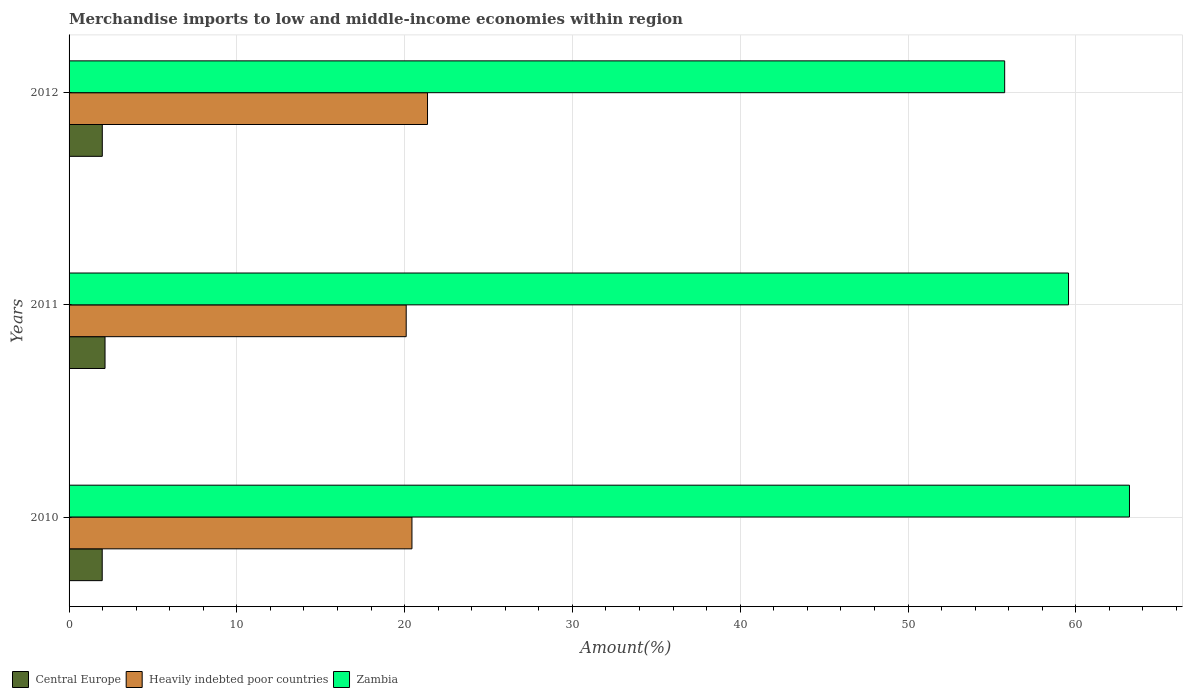How many different coloured bars are there?
Offer a terse response. 3. Are the number of bars on each tick of the Y-axis equal?
Make the answer very short. Yes. How many bars are there on the 1st tick from the top?
Make the answer very short. 3. How many bars are there on the 1st tick from the bottom?
Your response must be concise. 3. In how many cases, is the number of bars for a given year not equal to the number of legend labels?
Offer a very short reply. 0. What is the percentage of amount earned from merchandise imports in Heavily indebted poor countries in 2010?
Provide a succinct answer. 20.44. Across all years, what is the maximum percentage of amount earned from merchandise imports in Zambia?
Your answer should be very brief. 63.2. Across all years, what is the minimum percentage of amount earned from merchandise imports in Heavily indebted poor countries?
Offer a terse response. 20.09. In which year was the percentage of amount earned from merchandise imports in Central Europe minimum?
Provide a short and direct response. 2010. What is the total percentage of amount earned from merchandise imports in Central Europe in the graph?
Provide a short and direct response. 6.1. What is the difference between the percentage of amount earned from merchandise imports in Central Europe in 2010 and that in 2012?
Offer a terse response. -0. What is the difference between the percentage of amount earned from merchandise imports in Heavily indebted poor countries in 2010 and the percentage of amount earned from merchandise imports in Zambia in 2012?
Ensure brevity in your answer.  -35.33. What is the average percentage of amount earned from merchandise imports in Zambia per year?
Your response must be concise. 59.51. In the year 2010, what is the difference between the percentage of amount earned from merchandise imports in Zambia and percentage of amount earned from merchandise imports in Heavily indebted poor countries?
Provide a short and direct response. 42.76. In how many years, is the percentage of amount earned from merchandise imports in Heavily indebted poor countries greater than 44 %?
Offer a very short reply. 0. What is the ratio of the percentage of amount earned from merchandise imports in Zambia in 2010 to that in 2012?
Offer a terse response. 1.13. What is the difference between the highest and the second highest percentage of amount earned from merchandise imports in Heavily indebted poor countries?
Your response must be concise. 0.93. What is the difference between the highest and the lowest percentage of amount earned from merchandise imports in Heavily indebted poor countries?
Give a very brief answer. 1.27. What does the 2nd bar from the top in 2011 represents?
Give a very brief answer. Heavily indebted poor countries. What does the 3rd bar from the bottom in 2012 represents?
Provide a short and direct response. Zambia. Are all the bars in the graph horizontal?
Your answer should be compact. Yes. Are the values on the major ticks of X-axis written in scientific E-notation?
Your answer should be compact. No. Does the graph contain any zero values?
Ensure brevity in your answer.  No. Does the graph contain grids?
Offer a very short reply. Yes. Where does the legend appear in the graph?
Your answer should be compact. Bottom left. How many legend labels are there?
Make the answer very short. 3. How are the legend labels stacked?
Offer a very short reply. Horizontal. What is the title of the graph?
Give a very brief answer. Merchandise imports to low and middle-income economies within region. What is the label or title of the X-axis?
Make the answer very short. Amount(%). What is the label or title of the Y-axis?
Make the answer very short. Years. What is the Amount(%) in Central Europe in 2010?
Offer a very short reply. 1.98. What is the Amount(%) in Heavily indebted poor countries in 2010?
Offer a very short reply. 20.44. What is the Amount(%) of Zambia in 2010?
Offer a terse response. 63.2. What is the Amount(%) of Central Europe in 2011?
Keep it short and to the point. 2.14. What is the Amount(%) in Heavily indebted poor countries in 2011?
Offer a terse response. 20.09. What is the Amount(%) of Zambia in 2011?
Ensure brevity in your answer.  59.57. What is the Amount(%) in Central Europe in 2012?
Give a very brief answer. 1.98. What is the Amount(%) of Heavily indebted poor countries in 2012?
Give a very brief answer. 21.36. What is the Amount(%) of Zambia in 2012?
Ensure brevity in your answer.  55.76. Across all years, what is the maximum Amount(%) of Central Europe?
Your response must be concise. 2.14. Across all years, what is the maximum Amount(%) of Heavily indebted poor countries?
Make the answer very short. 21.36. Across all years, what is the maximum Amount(%) in Zambia?
Make the answer very short. 63.2. Across all years, what is the minimum Amount(%) of Central Europe?
Your answer should be compact. 1.98. Across all years, what is the minimum Amount(%) of Heavily indebted poor countries?
Keep it short and to the point. 20.09. Across all years, what is the minimum Amount(%) of Zambia?
Offer a very short reply. 55.76. What is the total Amount(%) in Central Europe in the graph?
Provide a succinct answer. 6.1. What is the total Amount(%) of Heavily indebted poor countries in the graph?
Offer a terse response. 61.89. What is the total Amount(%) in Zambia in the graph?
Provide a succinct answer. 178.53. What is the difference between the Amount(%) in Central Europe in 2010 and that in 2011?
Your answer should be compact. -0.17. What is the difference between the Amount(%) in Heavily indebted poor countries in 2010 and that in 2011?
Offer a very short reply. 0.34. What is the difference between the Amount(%) of Zambia in 2010 and that in 2011?
Provide a succinct answer. 3.63. What is the difference between the Amount(%) of Central Europe in 2010 and that in 2012?
Keep it short and to the point. -0. What is the difference between the Amount(%) of Heavily indebted poor countries in 2010 and that in 2012?
Ensure brevity in your answer.  -0.93. What is the difference between the Amount(%) of Zambia in 2010 and that in 2012?
Offer a terse response. 7.44. What is the difference between the Amount(%) of Central Europe in 2011 and that in 2012?
Give a very brief answer. 0.16. What is the difference between the Amount(%) in Heavily indebted poor countries in 2011 and that in 2012?
Give a very brief answer. -1.27. What is the difference between the Amount(%) in Zambia in 2011 and that in 2012?
Make the answer very short. 3.81. What is the difference between the Amount(%) in Central Europe in 2010 and the Amount(%) in Heavily indebted poor countries in 2011?
Give a very brief answer. -18.12. What is the difference between the Amount(%) of Central Europe in 2010 and the Amount(%) of Zambia in 2011?
Offer a very short reply. -57.59. What is the difference between the Amount(%) of Heavily indebted poor countries in 2010 and the Amount(%) of Zambia in 2011?
Offer a very short reply. -39.13. What is the difference between the Amount(%) in Central Europe in 2010 and the Amount(%) in Heavily indebted poor countries in 2012?
Provide a short and direct response. -19.39. What is the difference between the Amount(%) in Central Europe in 2010 and the Amount(%) in Zambia in 2012?
Your answer should be compact. -53.79. What is the difference between the Amount(%) of Heavily indebted poor countries in 2010 and the Amount(%) of Zambia in 2012?
Provide a succinct answer. -35.33. What is the difference between the Amount(%) of Central Europe in 2011 and the Amount(%) of Heavily indebted poor countries in 2012?
Make the answer very short. -19.22. What is the difference between the Amount(%) in Central Europe in 2011 and the Amount(%) in Zambia in 2012?
Offer a terse response. -53.62. What is the difference between the Amount(%) of Heavily indebted poor countries in 2011 and the Amount(%) of Zambia in 2012?
Give a very brief answer. -35.67. What is the average Amount(%) of Central Europe per year?
Provide a short and direct response. 2.03. What is the average Amount(%) of Heavily indebted poor countries per year?
Give a very brief answer. 20.63. What is the average Amount(%) in Zambia per year?
Your response must be concise. 59.51. In the year 2010, what is the difference between the Amount(%) of Central Europe and Amount(%) of Heavily indebted poor countries?
Your response must be concise. -18.46. In the year 2010, what is the difference between the Amount(%) of Central Europe and Amount(%) of Zambia?
Provide a short and direct response. -61.22. In the year 2010, what is the difference between the Amount(%) in Heavily indebted poor countries and Amount(%) in Zambia?
Offer a terse response. -42.76. In the year 2011, what is the difference between the Amount(%) of Central Europe and Amount(%) of Heavily indebted poor countries?
Make the answer very short. -17.95. In the year 2011, what is the difference between the Amount(%) in Central Europe and Amount(%) in Zambia?
Your answer should be very brief. -57.43. In the year 2011, what is the difference between the Amount(%) in Heavily indebted poor countries and Amount(%) in Zambia?
Give a very brief answer. -39.47. In the year 2012, what is the difference between the Amount(%) of Central Europe and Amount(%) of Heavily indebted poor countries?
Ensure brevity in your answer.  -19.38. In the year 2012, what is the difference between the Amount(%) in Central Europe and Amount(%) in Zambia?
Your answer should be very brief. -53.78. In the year 2012, what is the difference between the Amount(%) in Heavily indebted poor countries and Amount(%) in Zambia?
Give a very brief answer. -34.4. What is the ratio of the Amount(%) in Central Europe in 2010 to that in 2011?
Offer a terse response. 0.92. What is the ratio of the Amount(%) of Heavily indebted poor countries in 2010 to that in 2011?
Your answer should be compact. 1.02. What is the ratio of the Amount(%) in Zambia in 2010 to that in 2011?
Your response must be concise. 1.06. What is the ratio of the Amount(%) in Heavily indebted poor countries in 2010 to that in 2012?
Give a very brief answer. 0.96. What is the ratio of the Amount(%) in Zambia in 2010 to that in 2012?
Provide a short and direct response. 1.13. What is the ratio of the Amount(%) of Central Europe in 2011 to that in 2012?
Give a very brief answer. 1.08. What is the ratio of the Amount(%) in Heavily indebted poor countries in 2011 to that in 2012?
Ensure brevity in your answer.  0.94. What is the ratio of the Amount(%) in Zambia in 2011 to that in 2012?
Keep it short and to the point. 1.07. What is the difference between the highest and the second highest Amount(%) of Central Europe?
Offer a very short reply. 0.16. What is the difference between the highest and the second highest Amount(%) in Heavily indebted poor countries?
Give a very brief answer. 0.93. What is the difference between the highest and the second highest Amount(%) of Zambia?
Provide a succinct answer. 3.63. What is the difference between the highest and the lowest Amount(%) of Central Europe?
Your answer should be compact. 0.17. What is the difference between the highest and the lowest Amount(%) of Heavily indebted poor countries?
Keep it short and to the point. 1.27. What is the difference between the highest and the lowest Amount(%) in Zambia?
Make the answer very short. 7.44. 